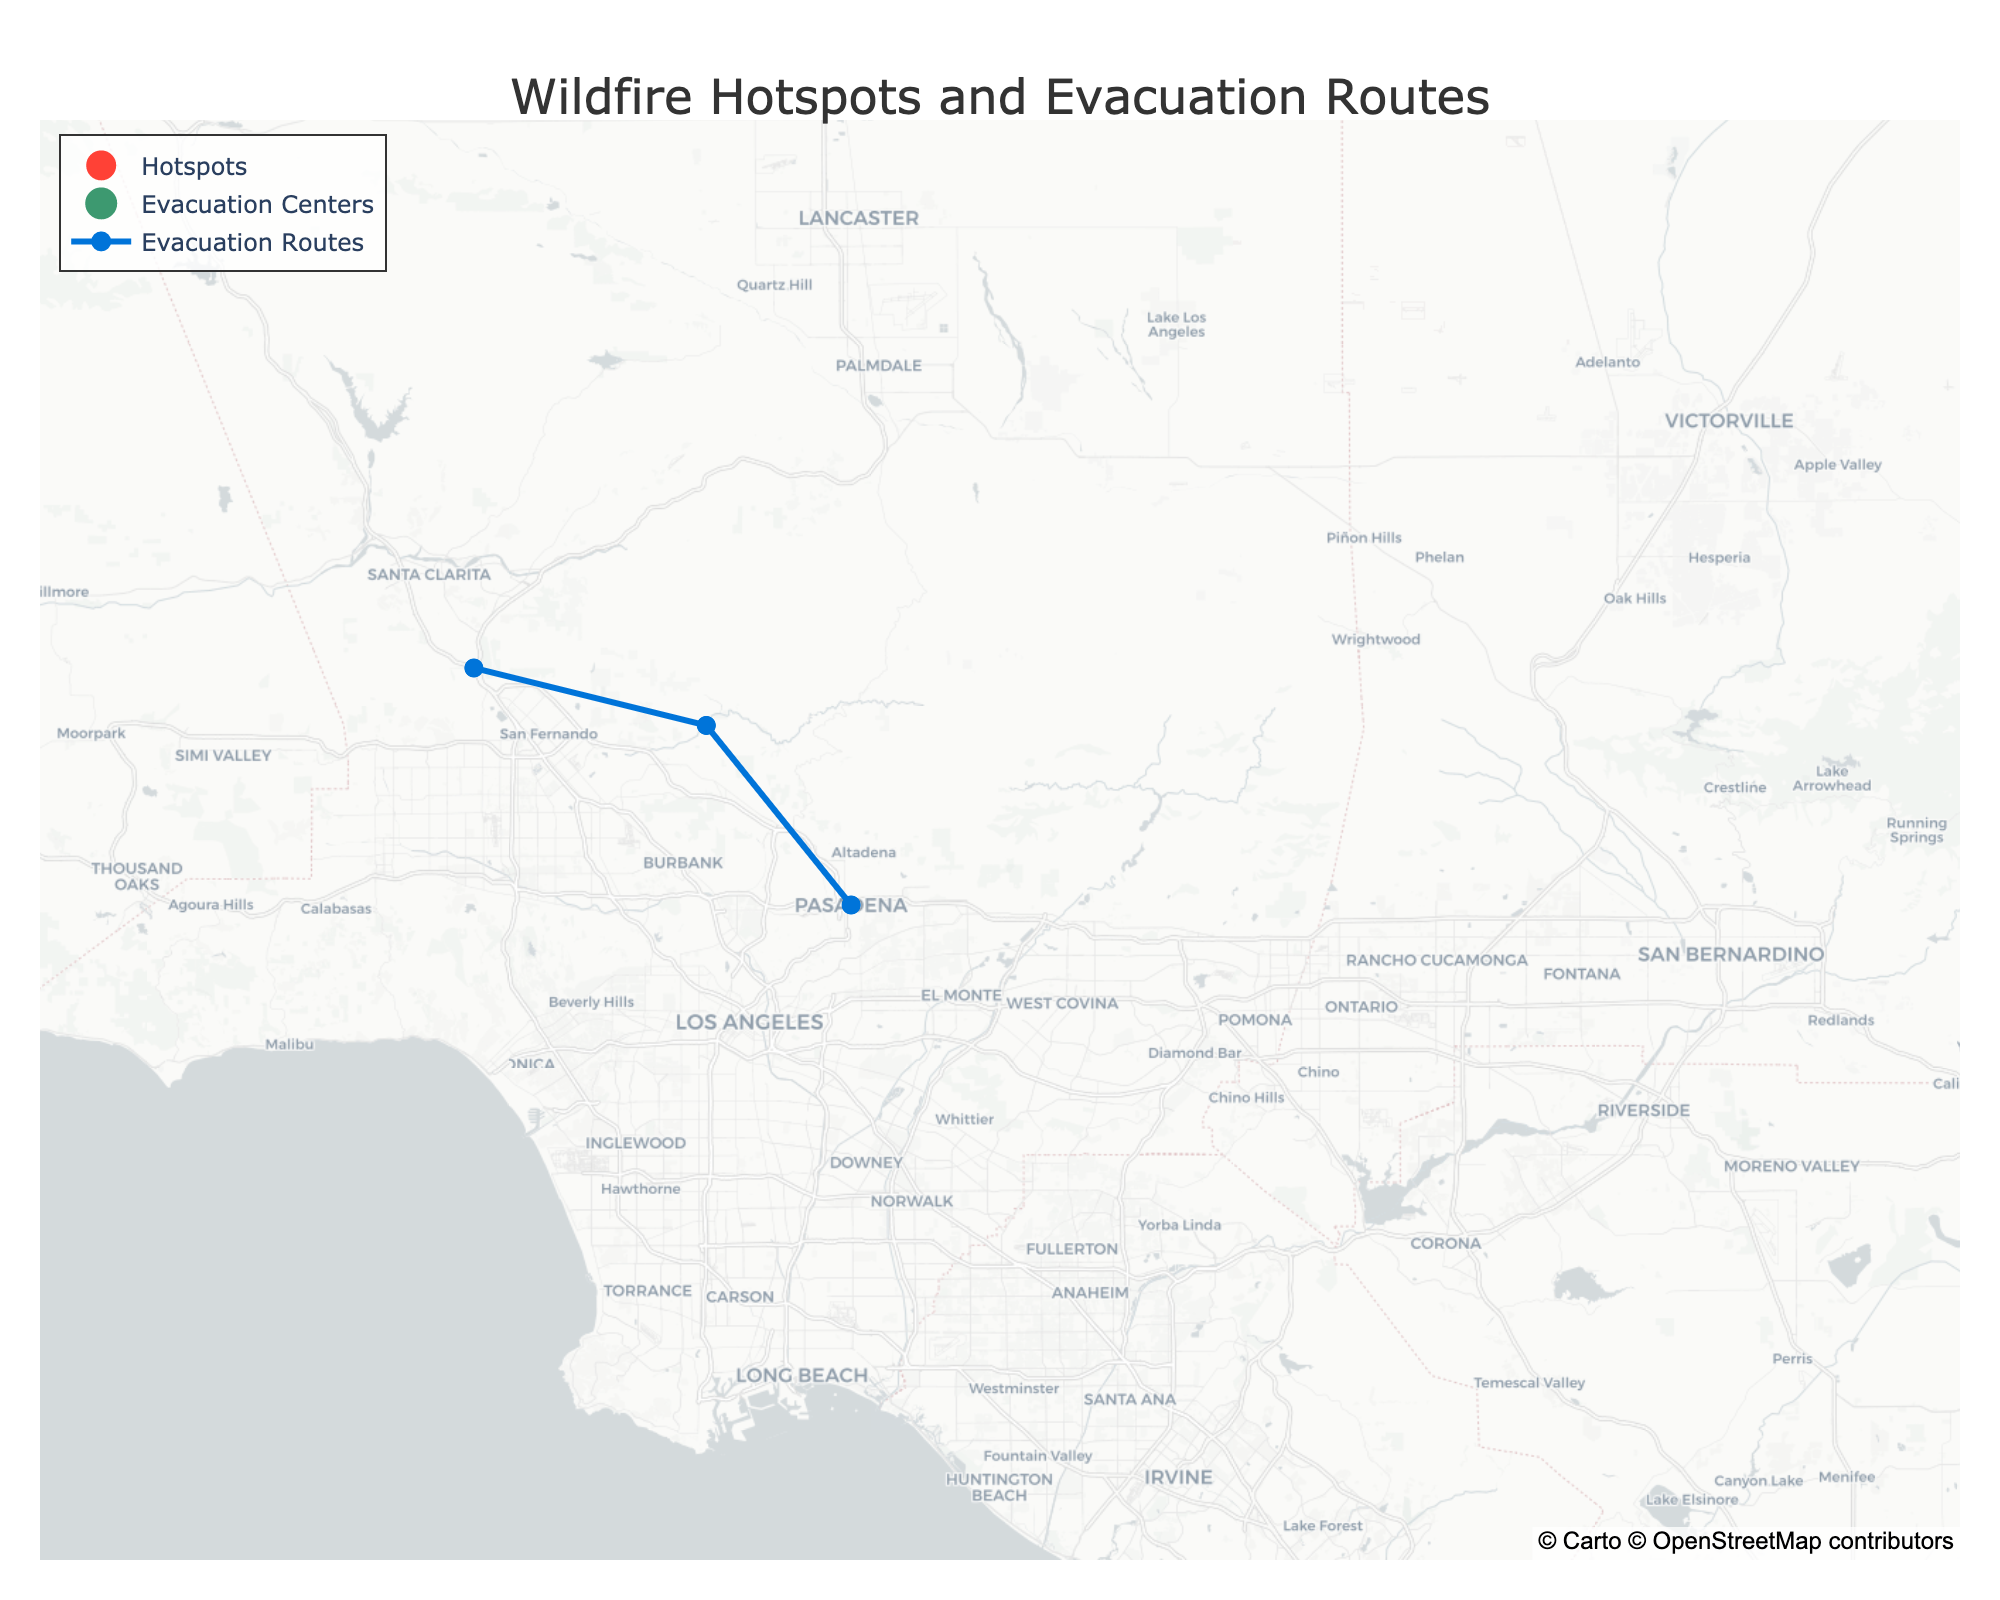What is the title of the figure? The title is the largest text at the top of the figure, centered. It provides a summary of what the figure represents.
Answer: Wildfire Hotspots and Evacuation Routes How many wildfire hotspots are shown on the map? Count the number of markers representing hotspots, which are colored and symbolized by a fire icon.
Answer: 4 What color represents the ‘High’ severity level for wildfire hotspots? Identify the color used for hotspots with a ‘High’ severity label in the figure.
Answer: Red Which hotspot has the highest severity level and what is its name? Look for the hotspot with the ‘Extreme’ severity level and note its name.
Answer: San Bernardino National Forest How many evacuation centers are indicated on the map? Count the markers representing evacuation centers, distinctively symbolized and colored differently from hotspots and routes.
Answer: 3 Which evacuation center is closest to downtown Los Angeles? Determine the evacuation center nearest to the latitude and longitude coordinates of downtown Los Angeles (34.0522, -118.2437).
Answer: Los Angeles Convention Center Which evacuation route is most northern on the map? Identify the evacuation route with the highest latitude value, indicating the northernmost position.
Answer: Foothill Boulevard How many evacuation routes are depicted on the map? Count the lines or markers that represent evacuation routes.
Answer: 3 Which evacuation routes have hotspots with ‘High’ severity connected to them? Identify the evacuation routes connected to hotspots labeled with ‘High’ severity by following the endpoints of the lines or checking routes mentioned in the hover text.
Answer: Interstate 210 and Interstate 5 What is the severity level of the San Jacinto Mountains hotspot, and what is its evacuation route? Find the marker for the San Jacinto Mountains hotspot and note the severity level and the evacuation route associated with it.
Answer: Moderate, State Route 74 